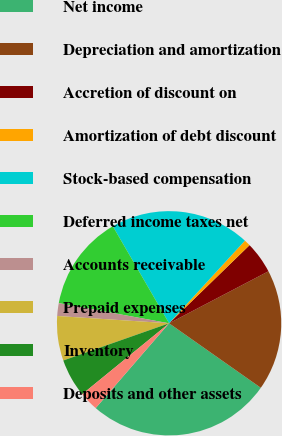Convert chart. <chart><loc_0><loc_0><loc_500><loc_500><pie_chart><fcel>Net income<fcel>Depreciation and amortization<fcel>Accretion of discount on<fcel>Amortization of debt discount<fcel>Stock-based compensation<fcel>Deferred income taxes net<fcel>Accounts receivable<fcel>Prepaid expenses<fcel>Inventory<fcel>Deposits and other assets<nl><fcel>26.6%<fcel>17.43%<fcel>4.59%<fcel>0.92%<fcel>20.18%<fcel>13.76%<fcel>1.84%<fcel>6.42%<fcel>5.51%<fcel>2.75%<nl></chart> 